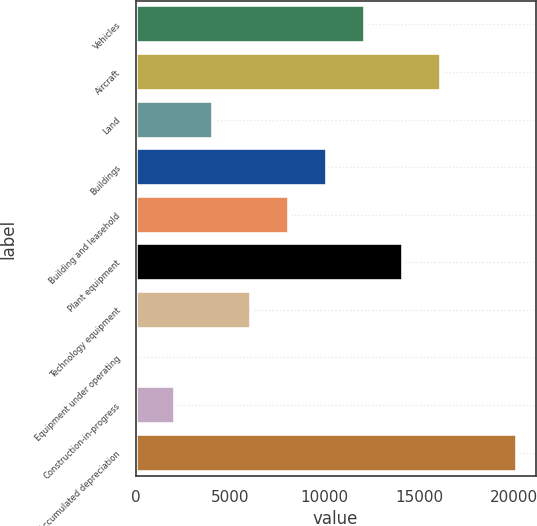Convert chart to OTSL. <chart><loc_0><loc_0><loc_500><loc_500><bar_chart><fcel>Vehicles<fcel>Aircraft<fcel>Land<fcel>Buildings<fcel>Building and leasehold<fcel>Plant equipment<fcel>Technology equipment<fcel>Equipment under operating<fcel>Construction-in-progress<fcel>Less Accumulated depreciation<nl><fcel>12115.8<fcel>16131.4<fcel>4084.6<fcel>10108<fcel>8100.2<fcel>14123.6<fcel>6092.4<fcel>69<fcel>2076.8<fcel>20147<nl></chart> 